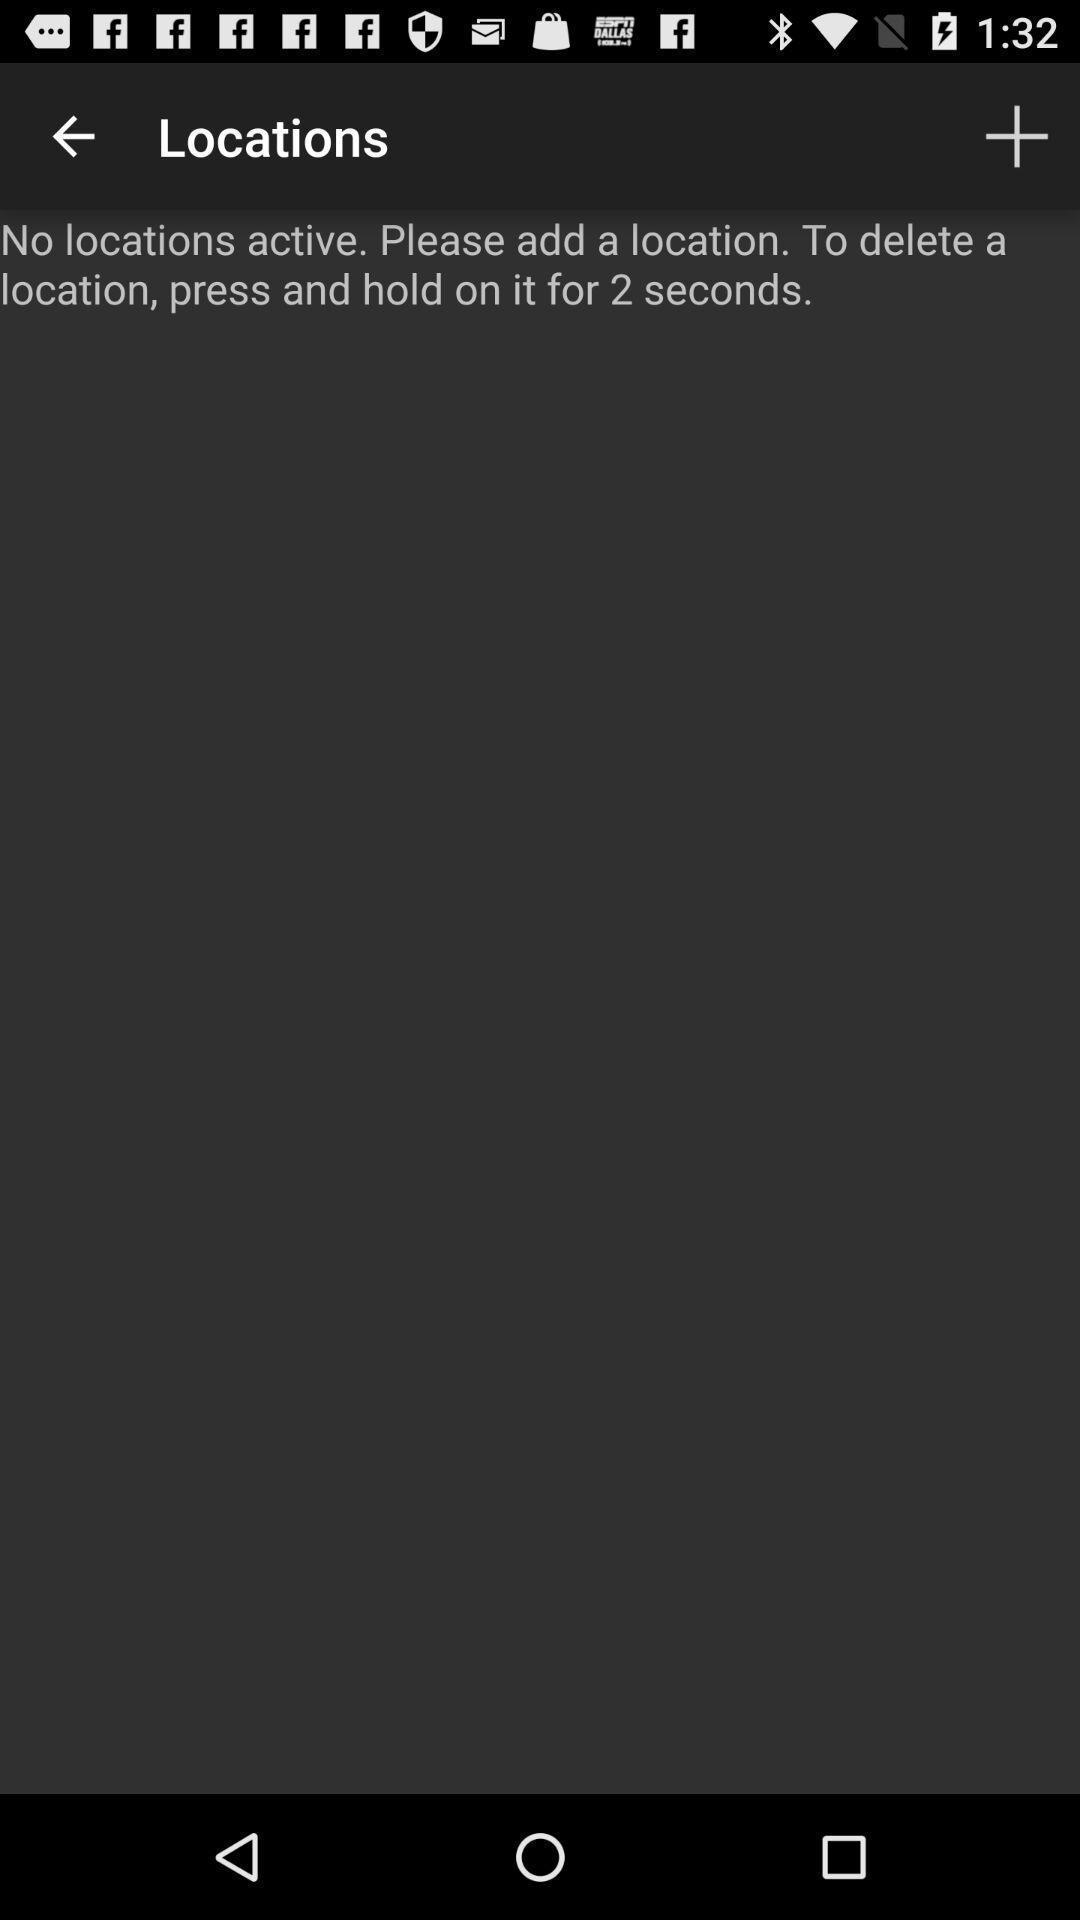Provide a description of this screenshot. Screen shows location details. 